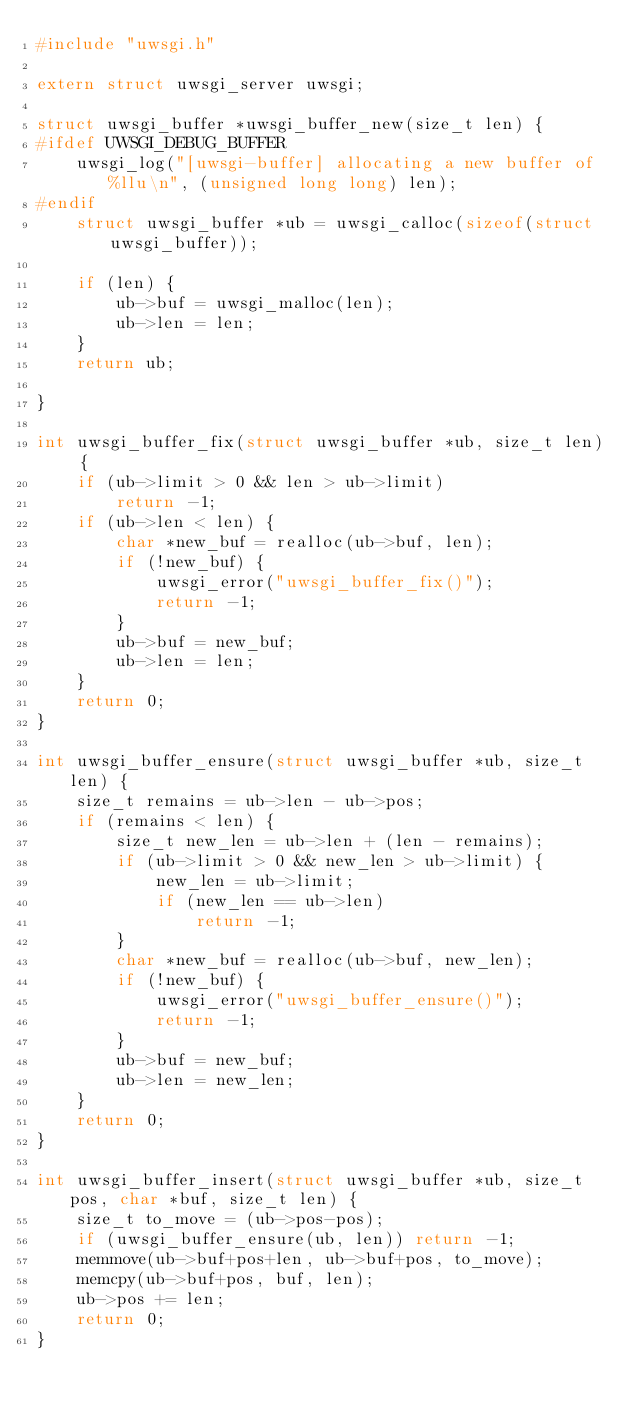<code> <loc_0><loc_0><loc_500><loc_500><_C_>#include "uwsgi.h"

extern struct uwsgi_server uwsgi;

struct uwsgi_buffer *uwsgi_buffer_new(size_t len) {
#ifdef UWSGI_DEBUG_BUFFER
	uwsgi_log("[uwsgi-buffer] allocating a new buffer of %llu\n", (unsigned long long) len);
#endif
	struct uwsgi_buffer *ub = uwsgi_calloc(sizeof(struct uwsgi_buffer));

	if (len) {
		ub->buf = uwsgi_malloc(len);
		ub->len = len;
	}
	return ub;

}

int uwsgi_buffer_fix(struct uwsgi_buffer *ub, size_t len) {
	if (ub->limit > 0 && len > ub->limit)
		return -1;
	if (ub->len < len) {
		char *new_buf = realloc(ub->buf, len);
		if (!new_buf) {
			uwsgi_error("uwsgi_buffer_fix()");
			return -1;
		}
		ub->buf = new_buf;
		ub->len = len;
	}
	return 0;
}

int uwsgi_buffer_ensure(struct uwsgi_buffer *ub, size_t len) {
	size_t remains = ub->len - ub->pos;
	if (remains < len) {
		size_t new_len = ub->len + (len - remains);
		if (ub->limit > 0 && new_len > ub->limit) {
			new_len = ub->limit;
			if (new_len == ub->len)
				return -1;
		}
		char *new_buf = realloc(ub->buf, new_len);
		if (!new_buf) {
			uwsgi_error("uwsgi_buffer_ensure()");
			return -1;
		}
		ub->buf = new_buf;
		ub->len = new_len;
	}
	return 0;
}

int uwsgi_buffer_insert(struct uwsgi_buffer *ub, size_t pos, char *buf, size_t len) {
	size_t to_move = (ub->pos-pos);
	if (uwsgi_buffer_ensure(ub, len)) return -1;
	memmove(ub->buf+pos+len, ub->buf+pos, to_move);
	memcpy(ub->buf+pos, buf, len);
	ub->pos += len;
	return 0;
}
</code> 